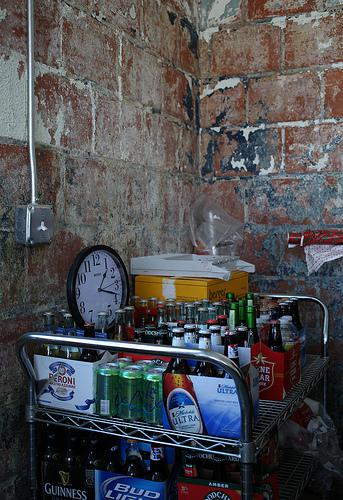Question: what time does the clock read?
Choices:
A. After one.
B. After two.
C. After three.
D. After four.
Answer with the letter. Answer: A Question: what is on the wall?
Choices:
A. A clock.
B. A painting.
C. A light switch.
D. A fan.
Answer with the letter. Answer: C Question: who took the photo?
Choices:
A. Steve.
B. Pablo.
C. Chris.
D. Pete.
Answer with the letter. Answer: D 